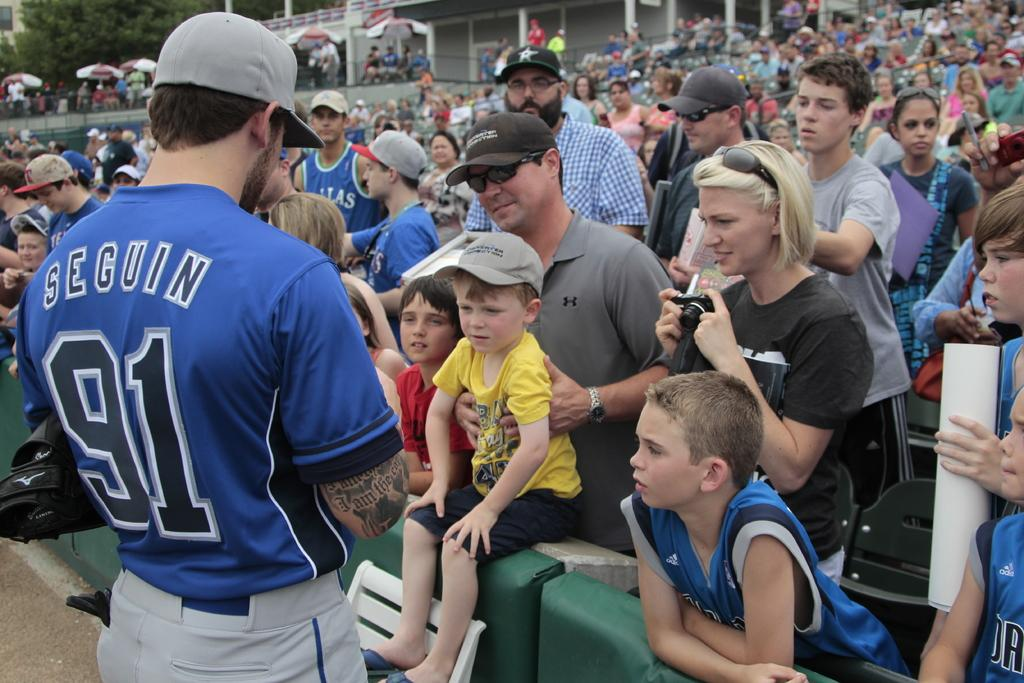<image>
Describe the image concisely. Seguin, baseball player #91, stands in front of a crowd in his blue baseball uniform. 